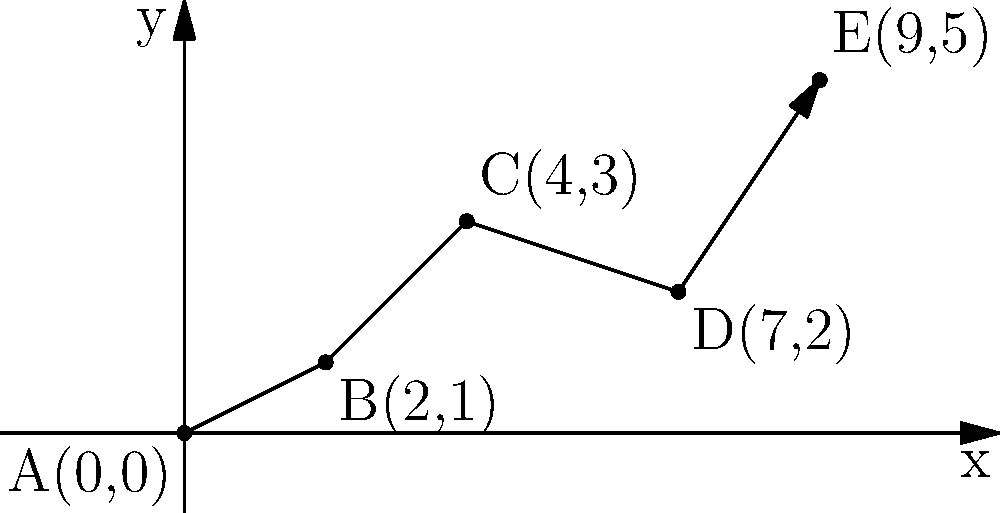Your grandmother's journey to a new country can be traced on a coordinate plane. The points A(0,0), B(2,1), C(4,3), D(7,2), and E(9,5) represent different locations on her route. Calculate the total distance she traveled using the distance formula between consecutive points. Round your answer to the nearest tenth. To solve this problem, we need to follow these steps:

1. Recall the distance formula: $d = \sqrt{(x_2-x_1)^2 + (y_2-y_1)^2}$

2. Calculate the distance between each consecutive pair of points:

   a) From A(0,0) to B(2,1):
      $d_{AB} = \sqrt{(2-0)^2 + (1-0)^2} = \sqrt{4 + 1} = \sqrt{5} \approx 2.2$

   b) From B(2,1) to C(4,3):
      $d_{BC} = \sqrt{(4-2)^2 + (3-1)^2} = \sqrt{4 + 4} = \sqrt{8} \approx 2.8$

   c) From C(4,3) to D(7,2):
      $d_{CD} = \sqrt{(7-4)^2 + (2-3)^2} = \sqrt{9 + 1} = \sqrt{10} \approx 3.2$

   d) From D(7,2) to E(9,5):
      $d_{DE} = \sqrt{(9-7)^2 + (5-2)^2} = \sqrt{4 + 9} = \sqrt{13} \approx 3.6$

3. Sum up all the distances:
   Total distance = $d_{AB} + d_{BC} + d_{CD} + d_{DE}$
                  $\approx 2.2 + 2.8 + 3.2 + 3.6$
                  $\approx 11.8$

4. Round to the nearest tenth:
   11.8 rounds to 11.8

Therefore, the total distance traveled is approximately 11.8 units.
Answer: 11.8 units 